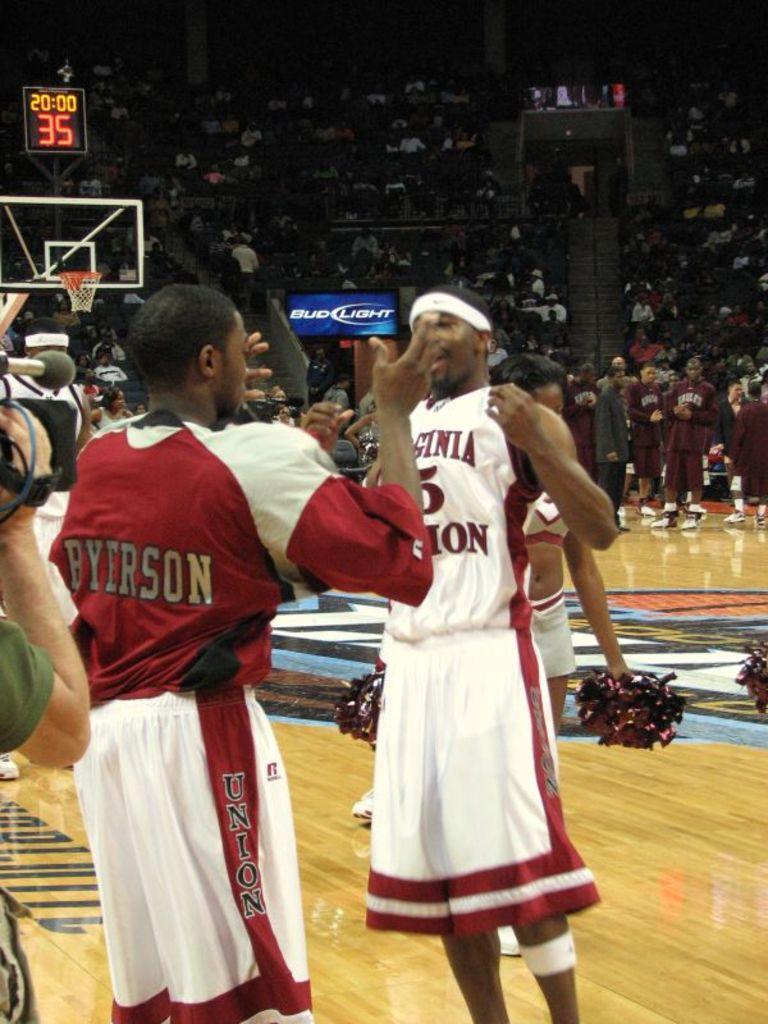What beer is advertised on the blue sign?
Your response must be concise. Bud light. 